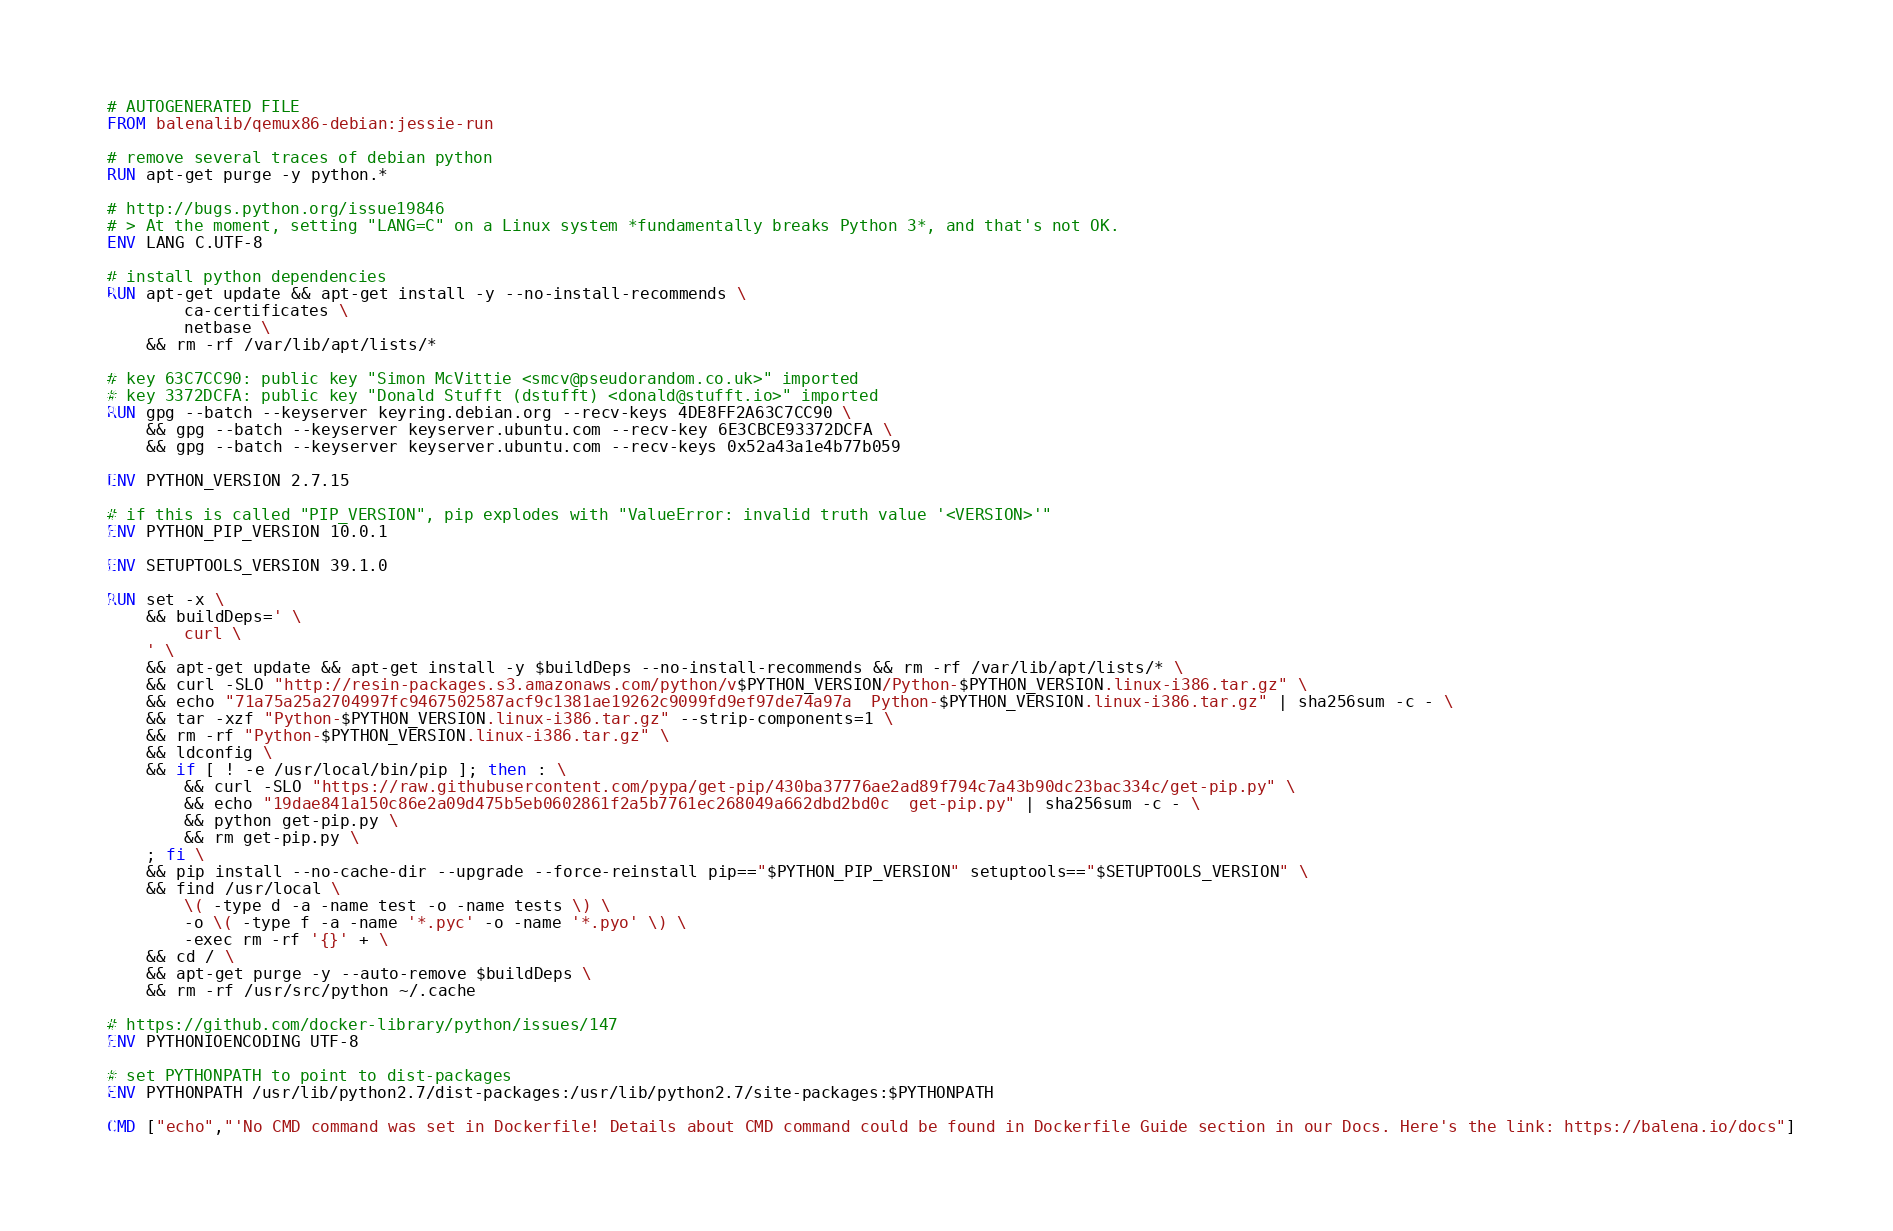Convert code to text. <code><loc_0><loc_0><loc_500><loc_500><_Dockerfile_># AUTOGENERATED FILE
FROM balenalib/qemux86-debian:jessie-run

# remove several traces of debian python
RUN apt-get purge -y python.*

# http://bugs.python.org/issue19846
# > At the moment, setting "LANG=C" on a Linux system *fundamentally breaks Python 3*, and that's not OK.
ENV LANG C.UTF-8

# install python dependencies
RUN apt-get update && apt-get install -y --no-install-recommends \
		ca-certificates \
		netbase \
	&& rm -rf /var/lib/apt/lists/*

# key 63C7CC90: public key "Simon McVittie <smcv@pseudorandom.co.uk>" imported
# key 3372DCFA: public key "Donald Stufft (dstufft) <donald@stufft.io>" imported
RUN gpg --batch --keyserver keyring.debian.org --recv-keys 4DE8FF2A63C7CC90 \
	&& gpg --batch --keyserver keyserver.ubuntu.com --recv-key 6E3CBCE93372DCFA \
	&& gpg --batch --keyserver keyserver.ubuntu.com --recv-keys 0x52a43a1e4b77b059

ENV PYTHON_VERSION 2.7.15

# if this is called "PIP_VERSION", pip explodes with "ValueError: invalid truth value '<VERSION>'"
ENV PYTHON_PIP_VERSION 10.0.1

ENV SETUPTOOLS_VERSION 39.1.0

RUN set -x \
	&& buildDeps=' \
		curl \
	' \
	&& apt-get update && apt-get install -y $buildDeps --no-install-recommends && rm -rf /var/lib/apt/lists/* \
	&& curl -SLO "http://resin-packages.s3.amazonaws.com/python/v$PYTHON_VERSION/Python-$PYTHON_VERSION.linux-i386.tar.gz" \
	&& echo "71a75a25a2704997fc9467502587acf9c1381ae19262c9099fd9ef97de74a97a  Python-$PYTHON_VERSION.linux-i386.tar.gz" | sha256sum -c - \
	&& tar -xzf "Python-$PYTHON_VERSION.linux-i386.tar.gz" --strip-components=1 \
	&& rm -rf "Python-$PYTHON_VERSION.linux-i386.tar.gz" \
	&& ldconfig \
	&& if [ ! -e /usr/local/bin/pip ]; then : \
		&& curl -SLO "https://raw.githubusercontent.com/pypa/get-pip/430ba37776ae2ad89f794c7a43b90dc23bac334c/get-pip.py" \
		&& echo "19dae841a150c86e2a09d475b5eb0602861f2a5b7761ec268049a662dbd2bd0c  get-pip.py" | sha256sum -c - \
		&& python get-pip.py \
		&& rm get-pip.py \
	; fi \
	&& pip install --no-cache-dir --upgrade --force-reinstall pip=="$PYTHON_PIP_VERSION" setuptools=="$SETUPTOOLS_VERSION" \
	&& find /usr/local \
		\( -type d -a -name test -o -name tests \) \
		-o \( -type f -a -name '*.pyc' -o -name '*.pyo' \) \
		-exec rm -rf '{}' + \
	&& cd / \
	&& apt-get purge -y --auto-remove $buildDeps \
	&& rm -rf /usr/src/python ~/.cache

# https://github.com/docker-library/python/issues/147
ENV PYTHONIOENCODING UTF-8

# set PYTHONPATH to point to dist-packages
ENV PYTHONPATH /usr/lib/python2.7/dist-packages:/usr/lib/python2.7/site-packages:$PYTHONPATH

CMD ["echo","'No CMD command was set in Dockerfile! Details about CMD command could be found in Dockerfile Guide section in our Docs. Here's the link: https://balena.io/docs"]</code> 